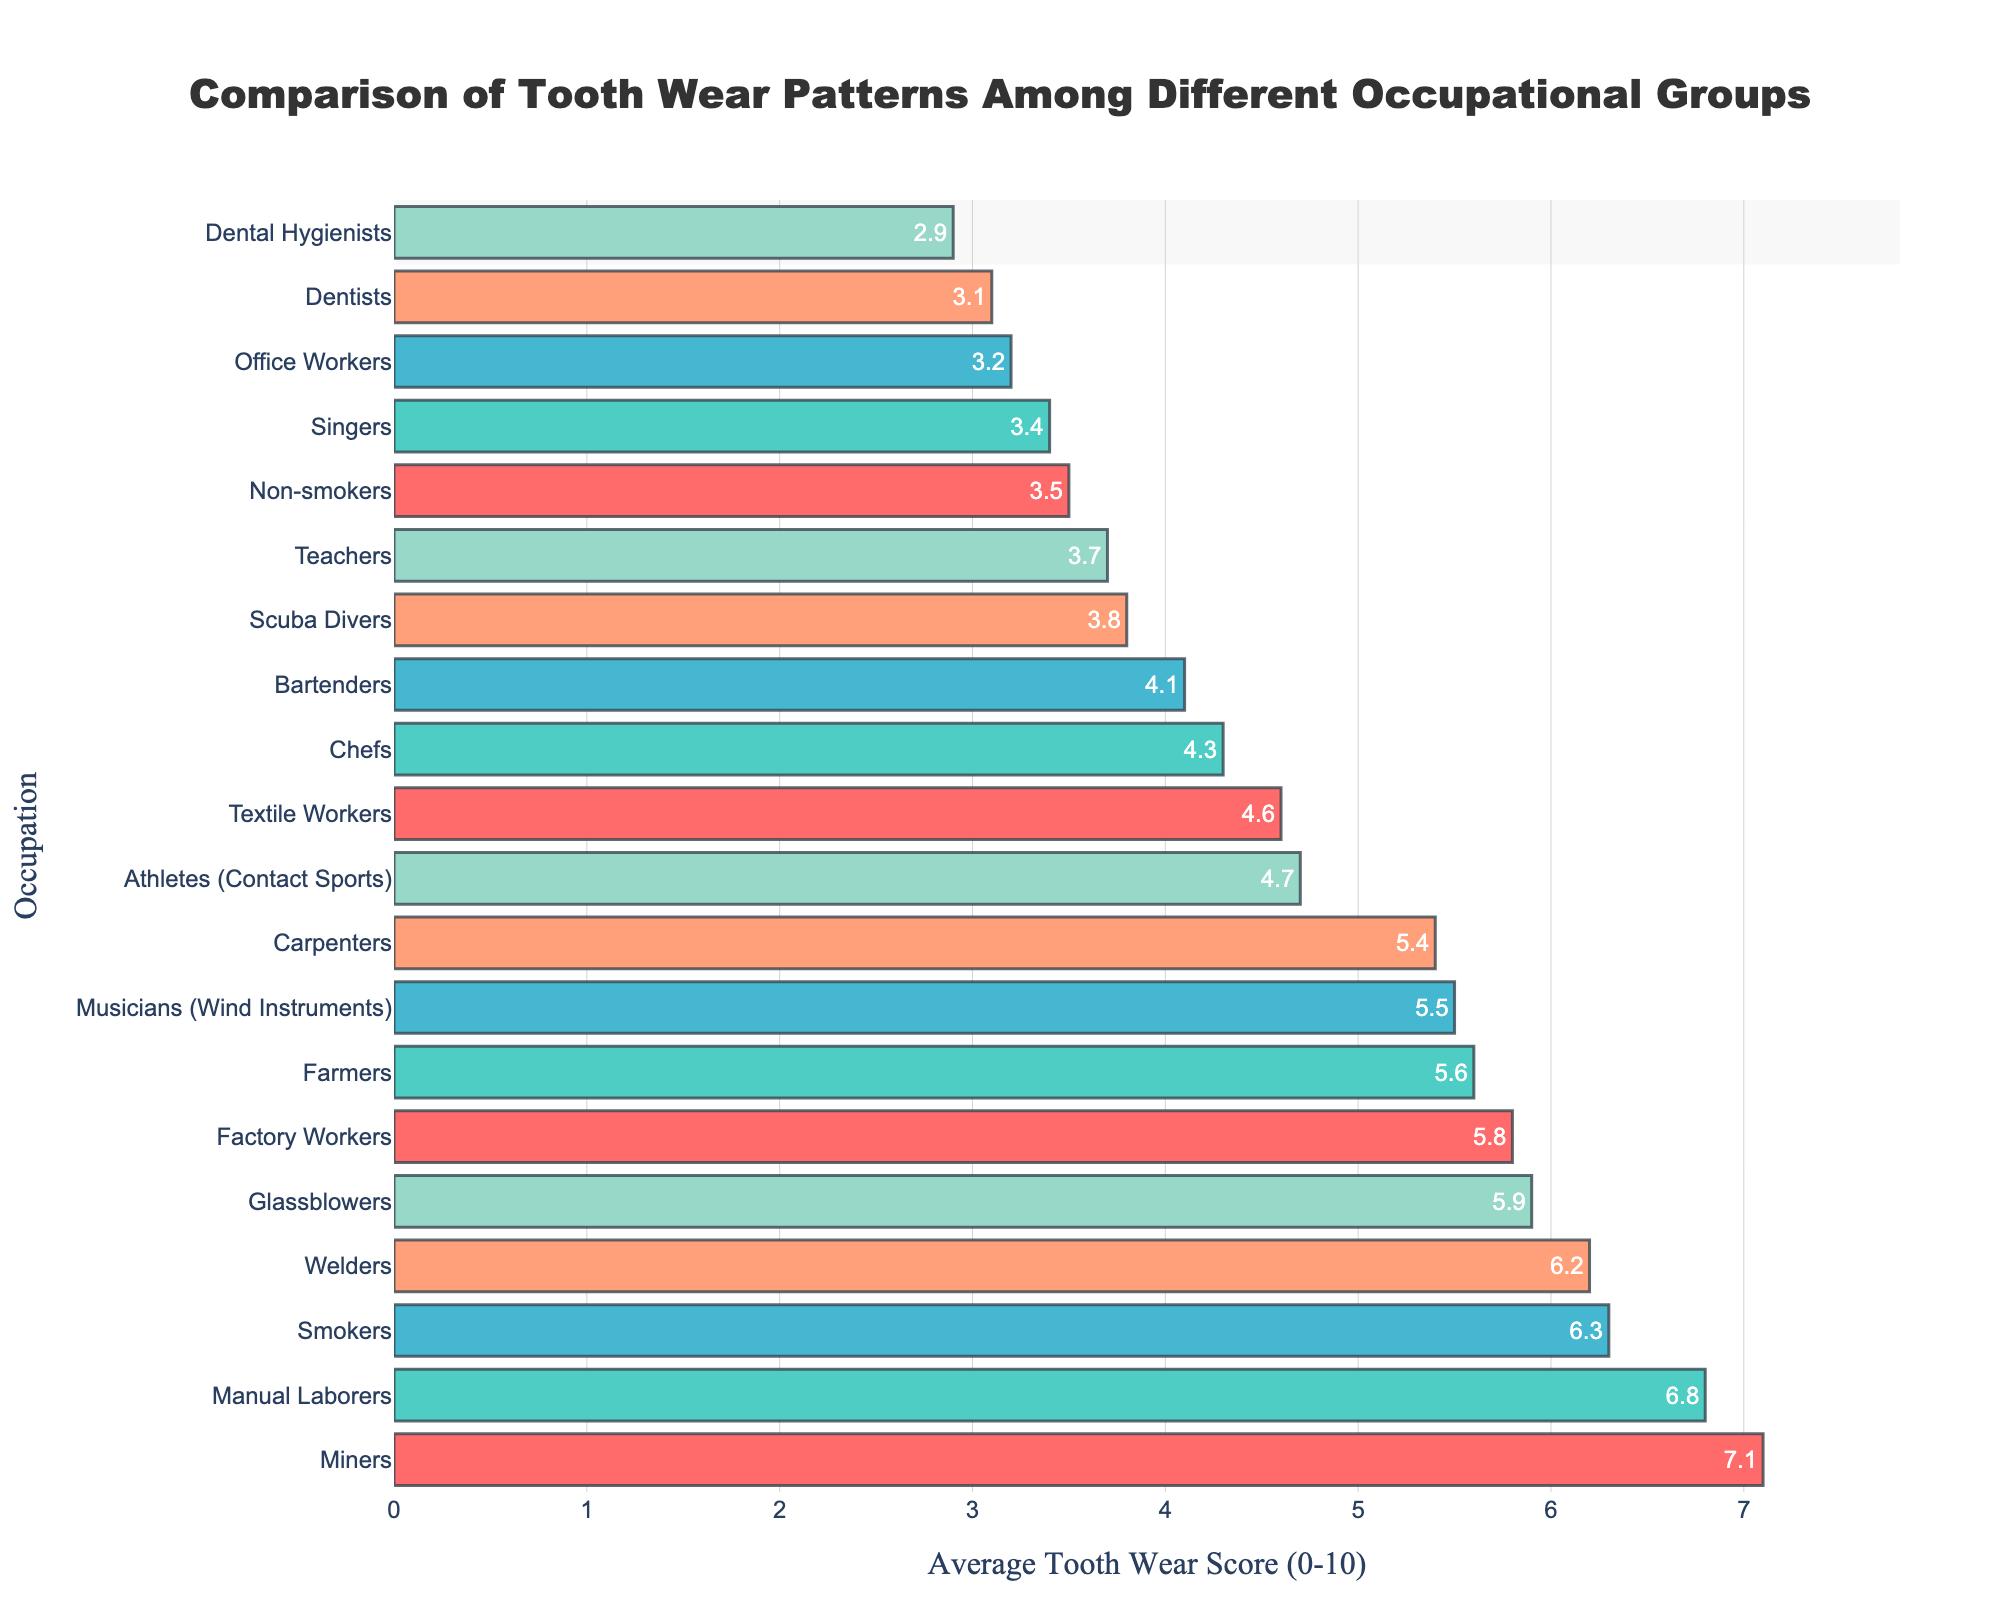How many occupational groups have an average tooth wear score greater than 5.0? Count the groups with scores greater than 5.0: Manual Laborers, Musicians (Wind Instruments), Miners, Glassblowers, Smokers, Farmers, Factory Workers, Welders, Carpenters. There are 9 groups.
Answer: 9 Which occupational group has the highest average tooth wear score? Identify the highest value on the x-axis and match it to the corresponding occupation on the y-axis. Miners have the highest score at 7.1.
Answer: Miners What is the difference in average tooth wear score between Office Workers and Manual Laborers? Subtract the average score of Office Workers (3.2) from Manual Laborers (6.8) to find the difference: 6.8 - 3.2 = 3.6.
Answer: 3.6 Which occupations have a higher average tooth wear score: Dental Hygienists or Dentists? Compare the scores of Dental Hygienists (2.9) and Dentists (3.1). Dentists have a slightly higher score.
Answer: Dentists What is the average tooth wear score of Farmers and Factory Workers combined? Add the scores of Farmers (5.6) and Factory Workers (5.8), then divide by 2: (5.6 + 5.8) / 2 = 5.7.
Answer: 5.7 Are there more occupations with an average tooth wear score below 4.0 or above 4.0? Count the groups with scores below 4.0: Office Workers, Dental Hygienists, Scuba Divers, Non-smokers, Teachers, Singers, Dentists (7 groups). Count the groups with scores above 4.0: Manual Laborers, Musicians (Wind Instruments), Athletes (Contact Sports), Chefs, Miners, Glassblowers, Smokers, Farmers, Factory Workers, Welders, Bartenders, Carpenters, Textile Workers (13 groups). There are more occupations with a score above 4.0.
Answer: Above 4.0 Which occupational group has the closest average tooth wear score to 5.0? Identify the group with the score closest to 5.0 by checking each group's score: Athletes (Contact Sports) have a score of 4.7, which is the closest to 5.0.
Answer: Athletes (Contact Sports) What is the total average tooth wear score for Chefs, Bartenders, and Textile Workers? Add the average scores of Chefs (4.3), Bartenders (4.1), and Textile Workers (4.6): 4.3 + 4.1 + 4.6 = 13.0.
Answer: 13.0 Do Carpenters or Musicians (Wind Instruments) have a higher average tooth wear score? Compare the scores of Carpenters (5.4) and Musicians (Wind Instruments) (5.5). Musicians (Wind Instruments) have a slightly higher score.
Answer: Musicians (Wind Instruments) 